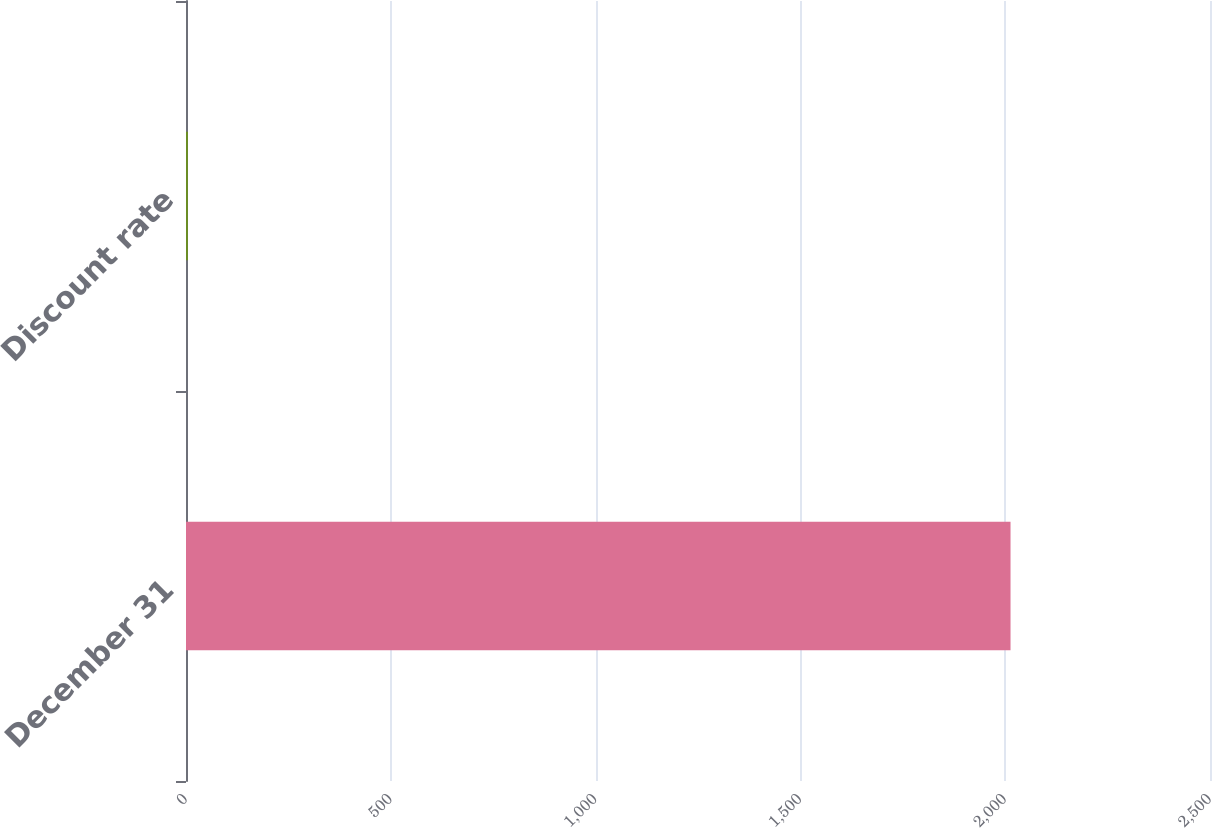Convert chart to OTSL. <chart><loc_0><loc_0><loc_500><loc_500><bar_chart><fcel>December 31<fcel>Discount rate<nl><fcel>2013<fcel>4.75<nl></chart> 